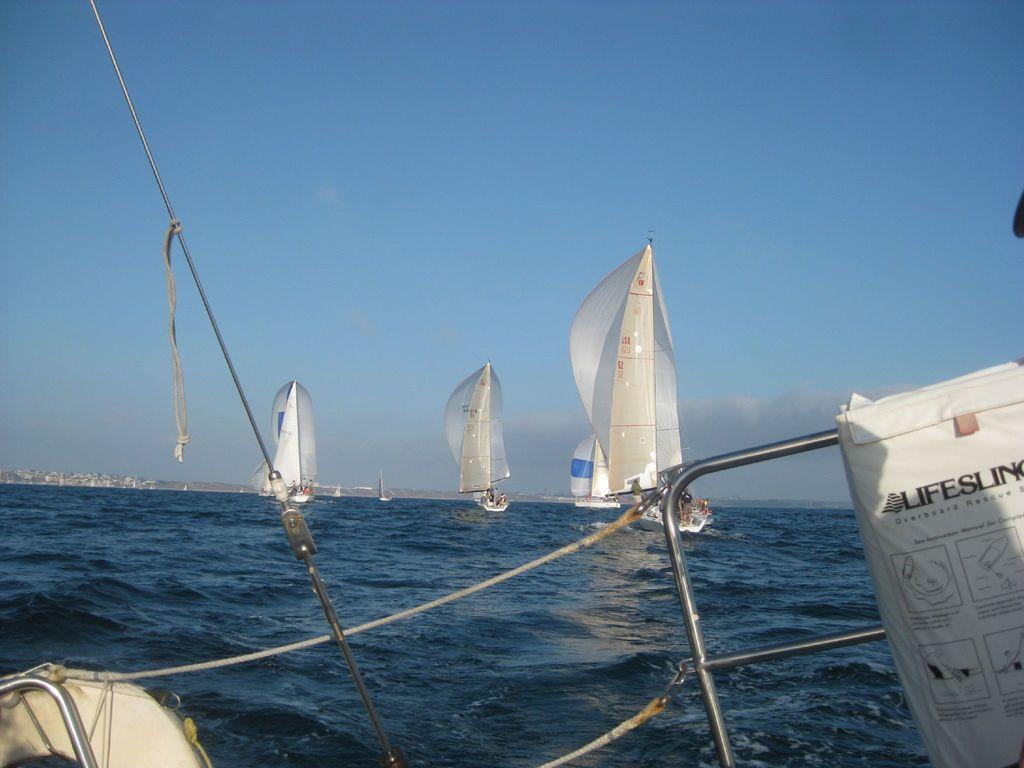What is the main subject of the image? The main subject of the image is ships. Where are the ships located in the image? The ships are in the center of the image. What can be seen in the background of the image? There is water visible in the image. What type of string can be seen tied to the mast of the ship in the image? There is no string tied to the mast of the ship in the image. How many sea creatures can be seen swimming near the ships in the image? There are no sea creatures visible in the image; it only shows ships and water. 